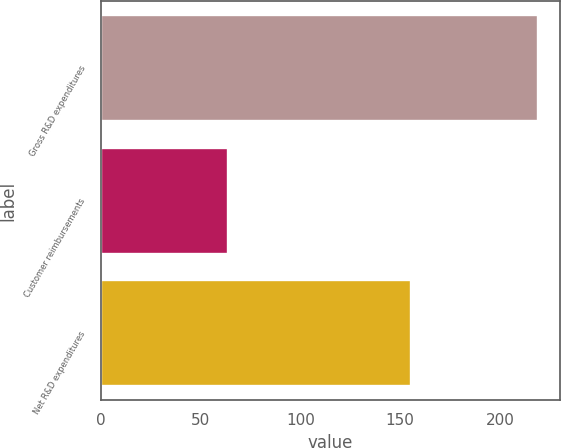Convert chart to OTSL. <chart><loc_0><loc_0><loc_500><loc_500><bar_chart><fcel>Gross R&D expenditures<fcel>Customer reimbursements<fcel>Net R&D expenditures<nl><fcel>219<fcel>63.8<fcel>155.2<nl></chart> 